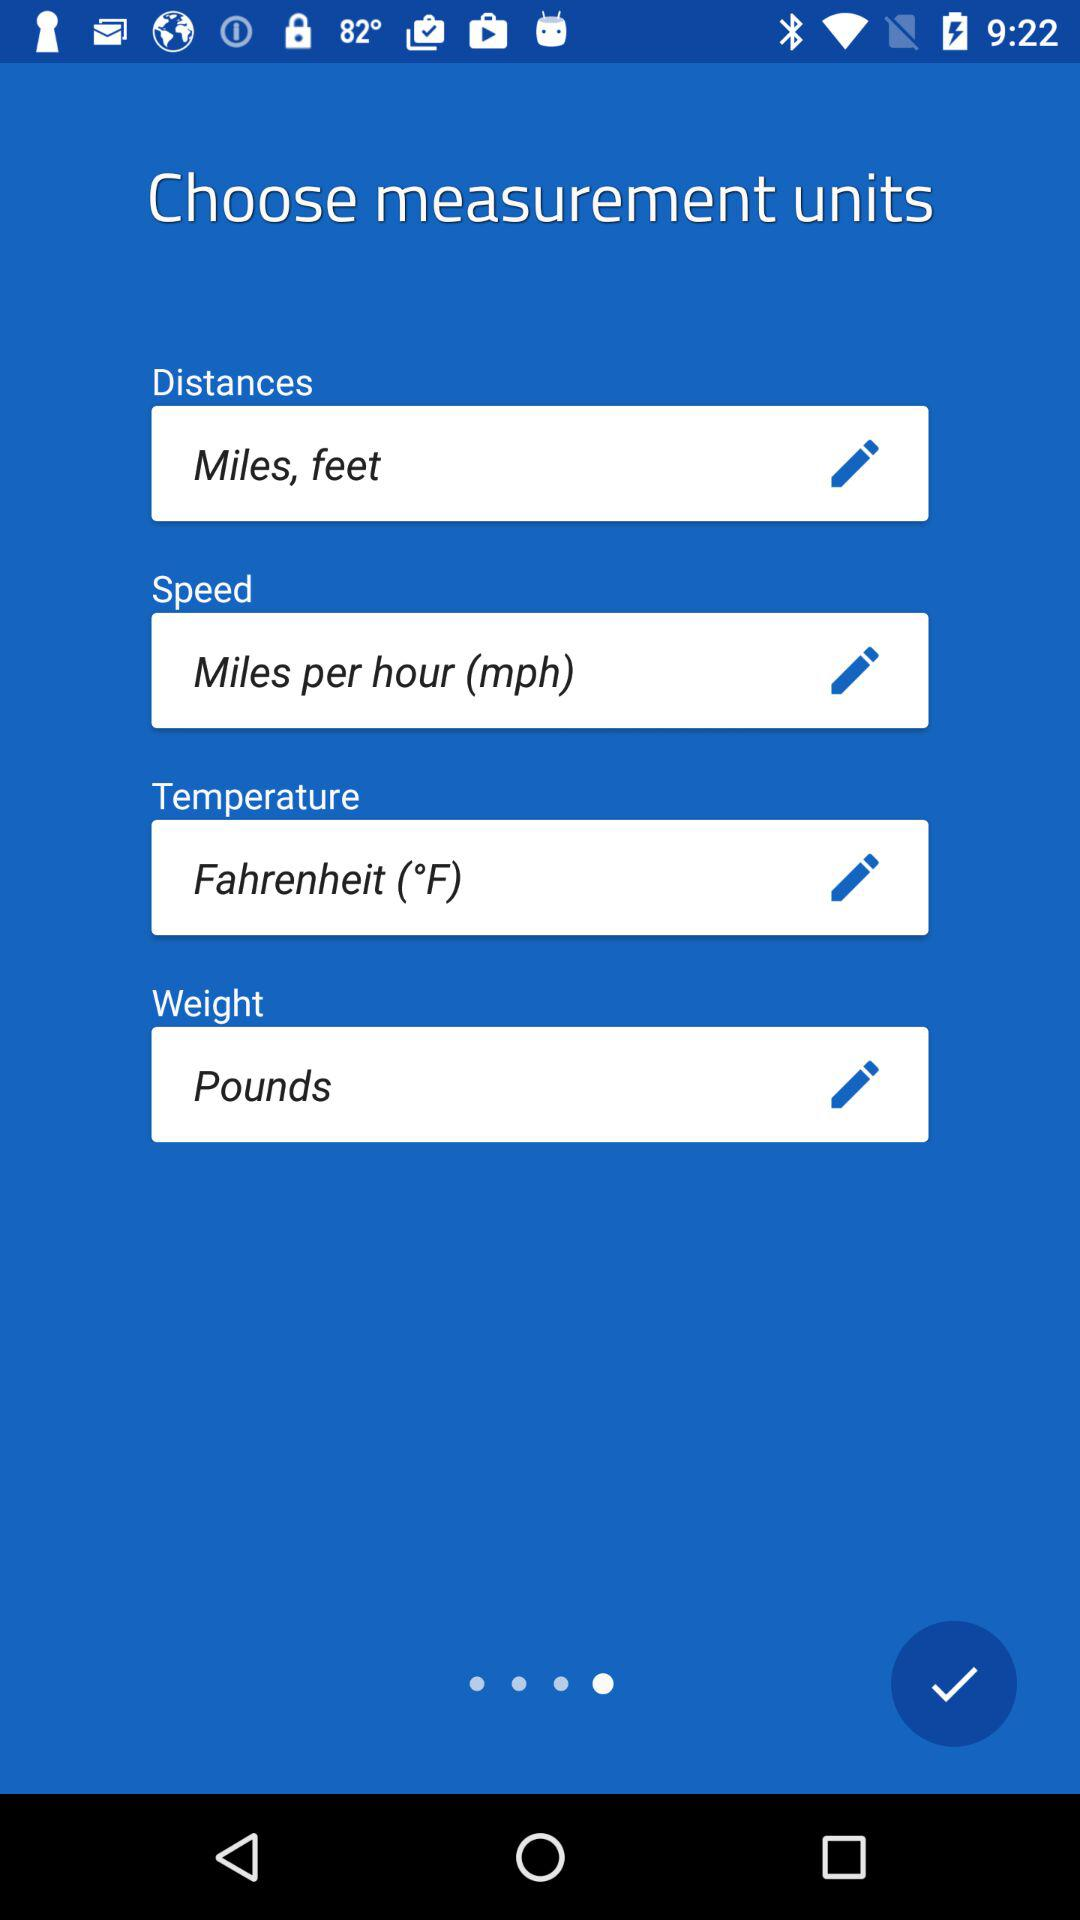What is the distance measurement unit? The distance measurement units are miles and feet. 